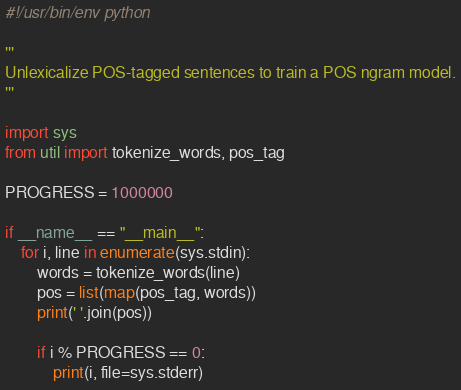<code> <loc_0><loc_0><loc_500><loc_500><_Python_>#!/usr/bin/env python

'''
Unlexicalize POS-tagged sentences to train a POS ngram model.
'''

import sys
from util import tokenize_words, pos_tag

PROGRESS = 1000000

if __name__ == "__main__":
    for i, line in enumerate(sys.stdin):
        words = tokenize_words(line)
        pos = list(map(pos_tag, words))
        print(' '.join(pos))
        
        if i % PROGRESS == 0:
            print(i, file=sys.stderr)</code> 